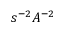Convert formula to latex. <formula><loc_0><loc_0><loc_500><loc_500>s ^ { - 2 } A ^ { - 2 }</formula> 